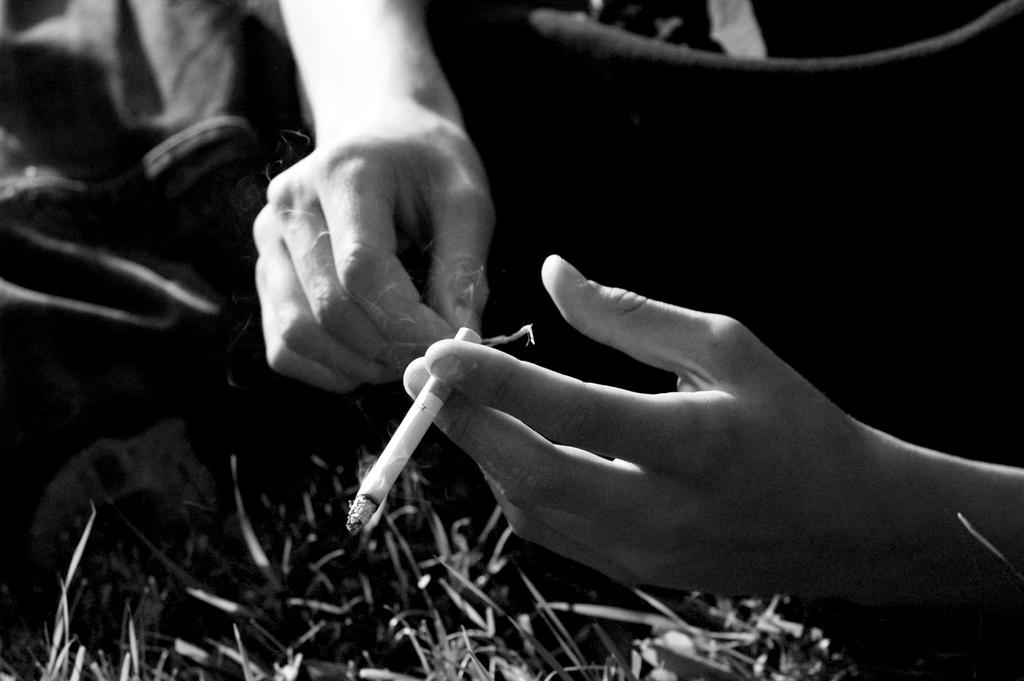What is the color scheme of the image? The image is black and white. What can be seen in the hands of the person in the image? The person is holding a cigarette. What type of vegetation is visible at the bottom of the image? There is grass at the bottom of the image. What type of crib can be seen in the image? There is no crib present in the image. How much salt is visible in the image? There is no salt visible in the image. 